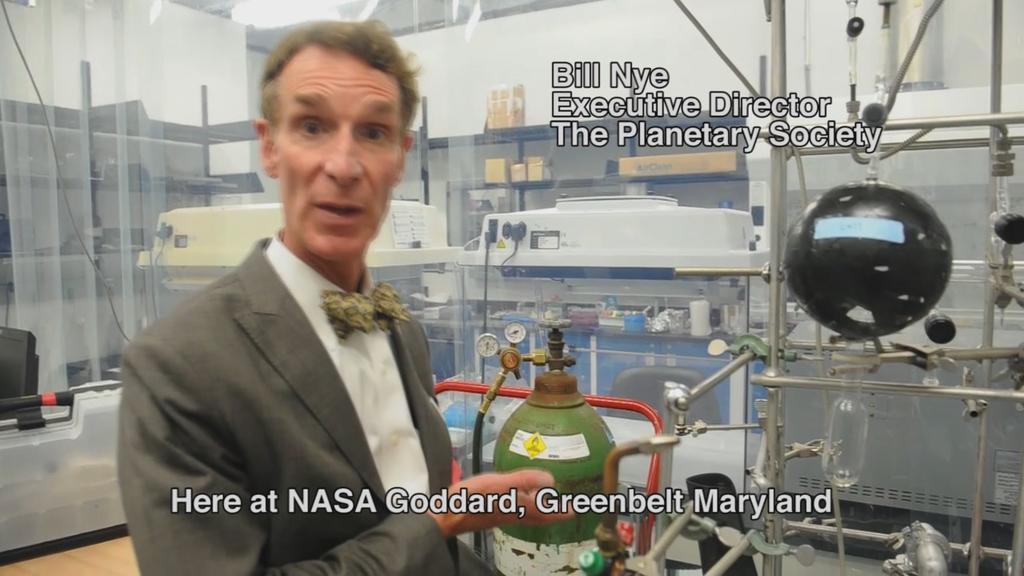Could you give a brief overview of what you see in this image? In the picture I can see a man on the left side wearing a suit and he is indicating his hands towards a cylinder. I can see the machines in the picture. I can see the metal rack shelves on the top left side. There is a light on the roof. 